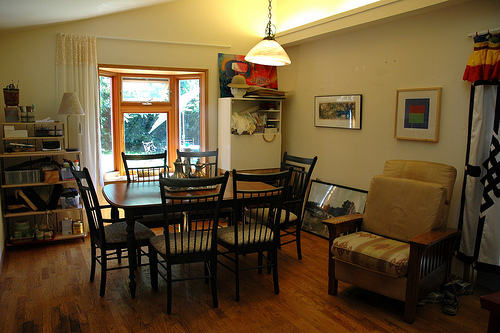<image>
Is the table under the lamp? Yes. The table is positioned underneath the lamp, with the lamp above it in the vertical space. Is there a window in front of the lamp? Yes. The window is positioned in front of the lamp, appearing closer to the camera viewpoint. 